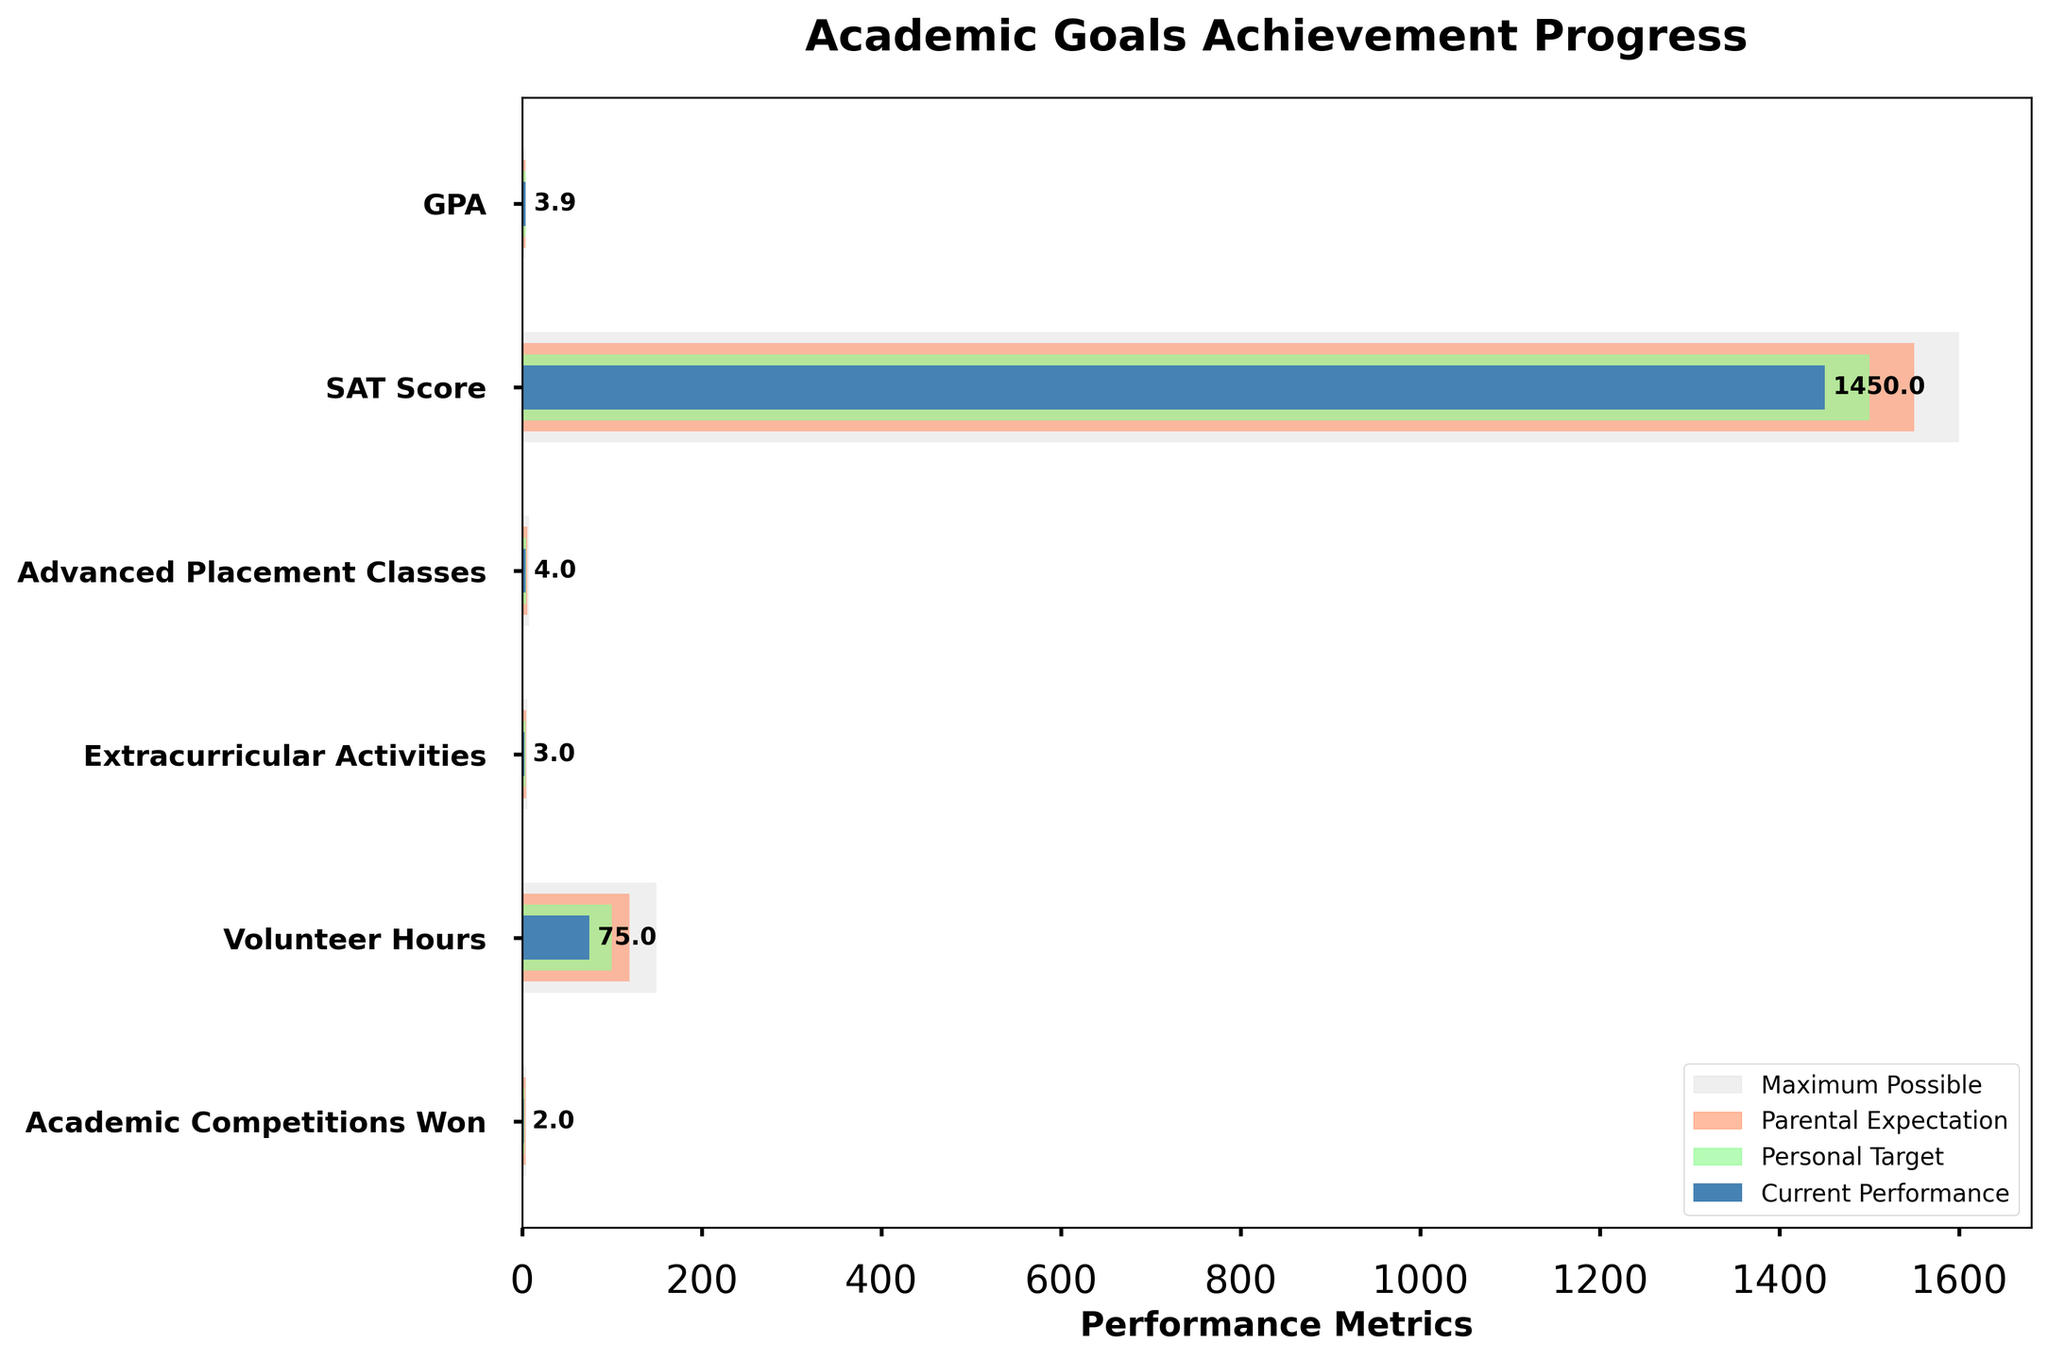What's the title of the figure? The title is generally found at the top of the figure and is marked with a larger and bolder font size to distinguish it. In this case, it's clearly indicated.
Answer: Academic Goals Achievement Progress What are the performance metrics on the horizontal axis? The horizontal axis shows the different performance metrics measured against each other. These should include GPA, SAT Score, Advanced Placement Classes, Extracurricular Activities, Volunteer Hours, and Academic Competitions Won. The figure specifies the units for each metric.
Answer: GPA, SAT Score, Advanced Placement Classes, Extracurricular Activities, Volunteer Hours, Academic Competitions Won Which subject shows the largest gap between parental expectation and personal target? By comparing the lengths of the orange and green bars for each subject, we can identify the subject with the largest gap. Here, the gap is clearly most significant for Extracurricular Activities (5 - 4 = 1).
Answer: Extracurricular Activities What is the current performance for SAT Score? The current performance is identified by the blue bar next to SAT Score. From the figure, this value is clearly labeled as 1450.
Answer: 1450 How many subjects have the personal target equal to the parental expectation? By comparing the lengths of the green and orange bars for each subject, we see that GPA (both 4.0) is the only subject where personal target equals parental expectation.
Answer: 1 Which subject is closest to reaching the personal target? To determine this, we look for the smallest gap between the blue bar (current performance) and the green bar (personal target). For GPA, the difference is minimal (4.0 - 3.9 = 0.1), the smallest among all the subjects.
Answer: GPA What is the difference between parental expectation and current performance for Volunteer Hours? For Volunteer Hours, the parental expectation is 120 and the current performance is 75. The difference is calculated as 120 - 75 = 45 hours.
Answer: 45 Which performance metric shows the highest value for maximum possible? By observing the longest gray bar, we find that the SAT Score has the highest value for maximum possible, which is 1600.
Answer: SAT Score What is the combined total of current performance for all subjects? Summing up the current performance values across all subjects: 3.9 (GPA) + 1450 (SAT Score) + 4 (AP Classes) + 3 (Extracurricular Activities) + 75 (Volunteer Hours) + 2 (Academic Competitions Won) = 1537.9.
Answer: 1537.9 Is there any subject where the current performance exceeds the personal target? By comparing the lengths of the blue and green bars across all subjects, we see that the current performance does not exceed the personal target for any subject, as all blue bars are shorter than the green bars.
Answer: No 